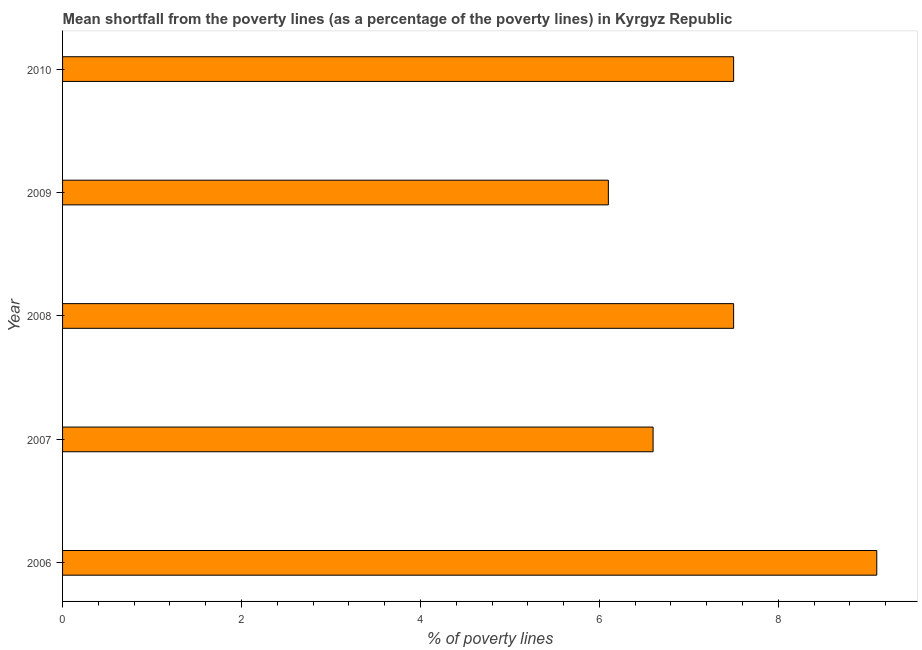What is the title of the graph?
Your answer should be very brief. Mean shortfall from the poverty lines (as a percentage of the poverty lines) in Kyrgyz Republic. What is the label or title of the X-axis?
Offer a terse response. % of poverty lines. What is the label or title of the Y-axis?
Offer a very short reply. Year. What is the poverty gap at national poverty lines in 2009?
Your answer should be very brief. 6.1. Across all years, what is the maximum poverty gap at national poverty lines?
Make the answer very short. 9.1. Across all years, what is the minimum poverty gap at national poverty lines?
Give a very brief answer. 6.1. In which year was the poverty gap at national poverty lines maximum?
Your response must be concise. 2006. In which year was the poverty gap at national poverty lines minimum?
Offer a very short reply. 2009. What is the sum of the poverty gap at national poverty lines?
Your answer should be very brief. 36.8. What is the average poverty gap at national poverty lines per year?
Your answer should be very brief. 7.36. Do a majority of the years between 2006 and 2007 (inclusive) have poverty gap at national poverty lines greater than 3.6 %?
Your answer should be very brief. Yes. What is the ratio of the poverty gap at national poverty lines in 2006 to that in 2007?
Your response must be concise. 1.38. Is the poverty gap at national poverty lines in 2007 less than that in 2008?
Ensure brevity in your answer.  Yes. What is the difference between the highest and the lowest poverty gap at national poverty lines?
Ensure brevity in your answer.  3. How many years are there in the graph?
Provide a succinct answer. 5. What is the difference between two consecutive major ticks on the X-axis?
Make the answer very short. 2. What is the % of poverty lines of 2007?
Provide a short and direct response. 6.6. What is the % of poverty lines in 2008?
Your answer should be very brief. 7.5. What is the % of poverty lines in 2009?
Your answer should be very brief. 6.1. What is the % of poverty lines in 2010?
Make the answer very short. 7.5. What is the difference between the % of poverty lines in 2006 and 2010?
Keep it short and to the point. 1.6. What is the difference between the % of poverty lines in 2007 and 2008?
Keep it short and to the point. -0.9. What is the difference between the % of poverty lines in 2008 and 2009?
Provide a succinct answer. 1.4. What is the difference between the % of poverty lines in 2008 and 2010?
Give a very brief answer. 0. What is the difference between the % of poverty lines in 2009 and 2010?
Make the answer very short. -1.4. What is the ratio of the % of poverty lines in 2006 to that in 2007?
Ensure brevity in your answer.  1.38. What is the ratio of the % of poverty lines in 2006 to that in 2008?
Ensure brevity in your answer.  1.21. What is the ratio of the % of poverty lines in 2006 to that in 2009?
Provide a short and direct response. 1.49. What is the ratio of the % of poverty lines in 2006 to that in 2010?
Ensure brevity in your answer.  1.21. What is the ratio of the % of poverty lines in 2007 to that in 2009?
Offer a terse response. 1.08. What is the ratio of the % of poverty lines in 2007 to that in 2010?
Offer a terse response. 0.88. What is the ratio of the % of poverty lines in 2008 to that in 2009?
Offer a very short reply. 1.23. What is the ratio of the % of poverty lines in 2009 to that in 2010?
Your answer should be compact. 0.81. 